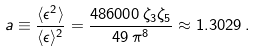Convert formula to latex. <formula><loc_0><loc_0><loc_500><loc_500>a \equiv \frac { \langle \epsilon ^ { 2 } \rangle } { \langle \epsilon \rangle ^ { 2 } } = \frac { 4 8 6 0 0 0 \, \zeta _ { 3 } \zeta _ { 5 } } { 4 9 \, \pi ^ { 8 } } \approx 1 . 3 0 2 9 \, .</formula> 